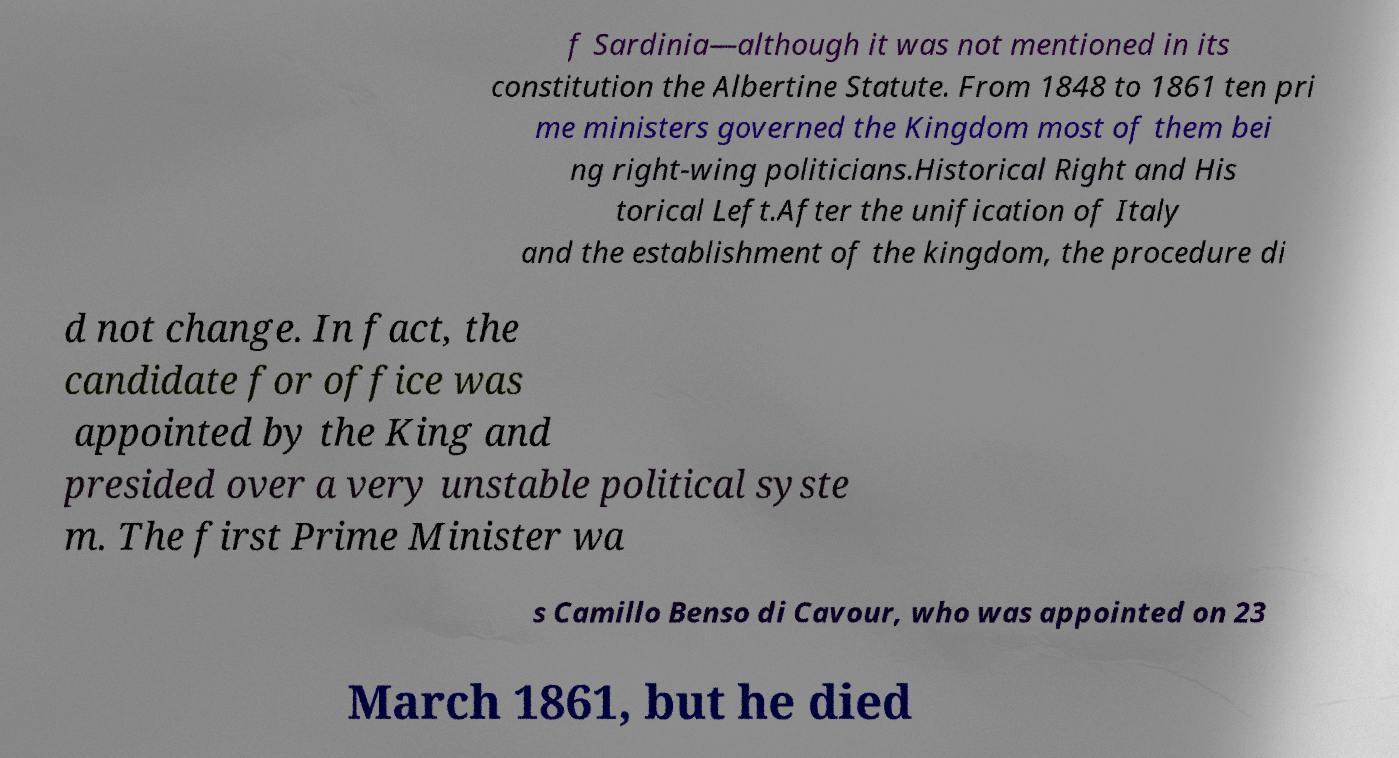Could you assist in decoding the text presented in this image and type it out clearly? f Sardinia—although it was not mentioned in its constitution the Albertine Statute. From 1848 to 1861 ten pri me ministers governed the Kingdom most of them bei ng right-wing politicians.Historical Right and His torical Left.After the unification of Italy and the establishment of the kingdom, the procedure di d not change. In fact, the candidate for office was appointed by the King and presided over a very unstable political syste m. The first Prime Minister wa s Camillo Benso di Cavour, who was appointed on 23 March 1861, but he died 